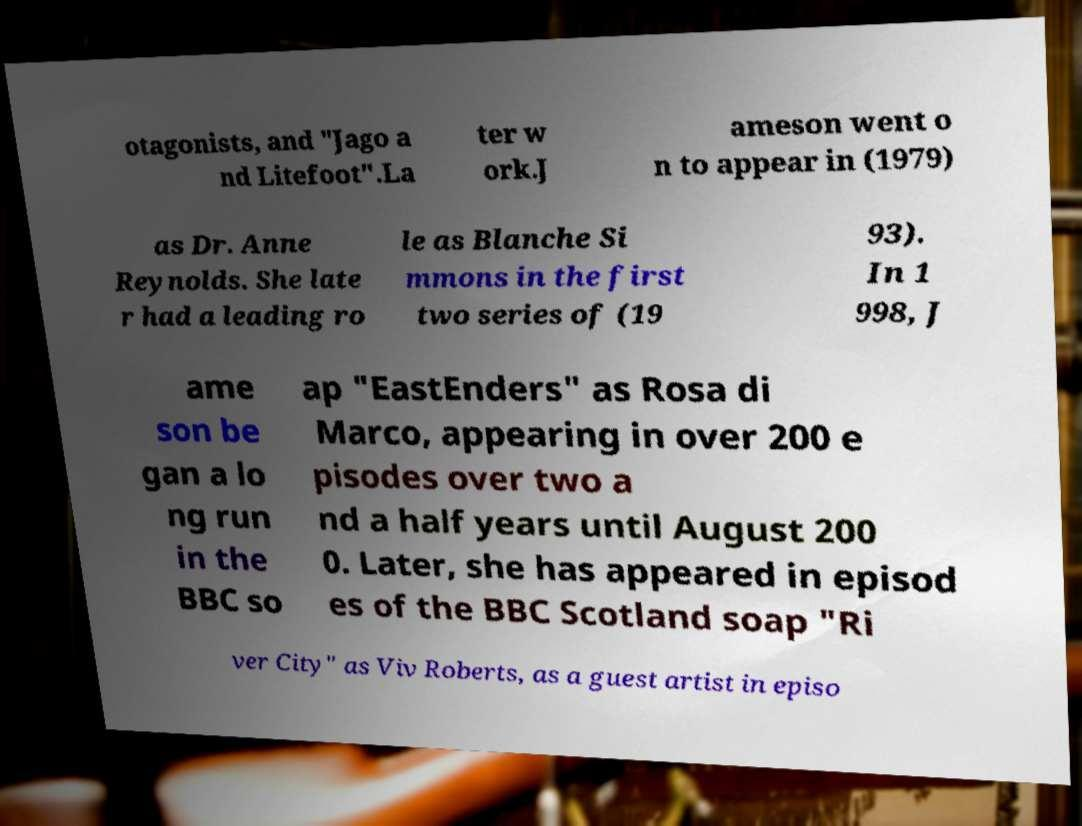What messages or text are displayed in this image? I need them in a readable, typed format. otagonists, and "Jago a nd Litefoot".La ter w ork.J ameson went o n to appear in (1979) as Dr. Anne Reynolds. She late r had a leading ro le as Blanche Si mmons in the first two series of (19 93). In 1 998, J ame son be gan a lo ng run in the BBC so ap "EastEnders" as Rosa di Marco, appearing in over 200 e pisodes over two a nd a half years until August 200 0. Later, she has appeared in episod es of the BBC Scotland soap "Ri ver City" as Viv Roberts, as a guest artist in episo 